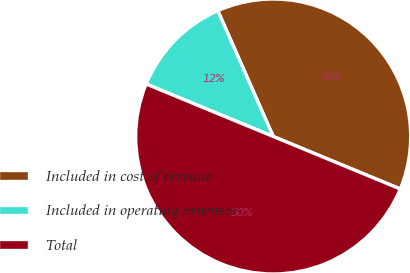Convert chart. <chart><loc_0><loc_0><loc_500><loc_500><pie_chart><fcel>Included in cost of revenue<fcel>Included in operating expenses<fcel>Total<nl><fcel>37.84%<fcel>12.16%<fcel>50.0%<nl></chart> 